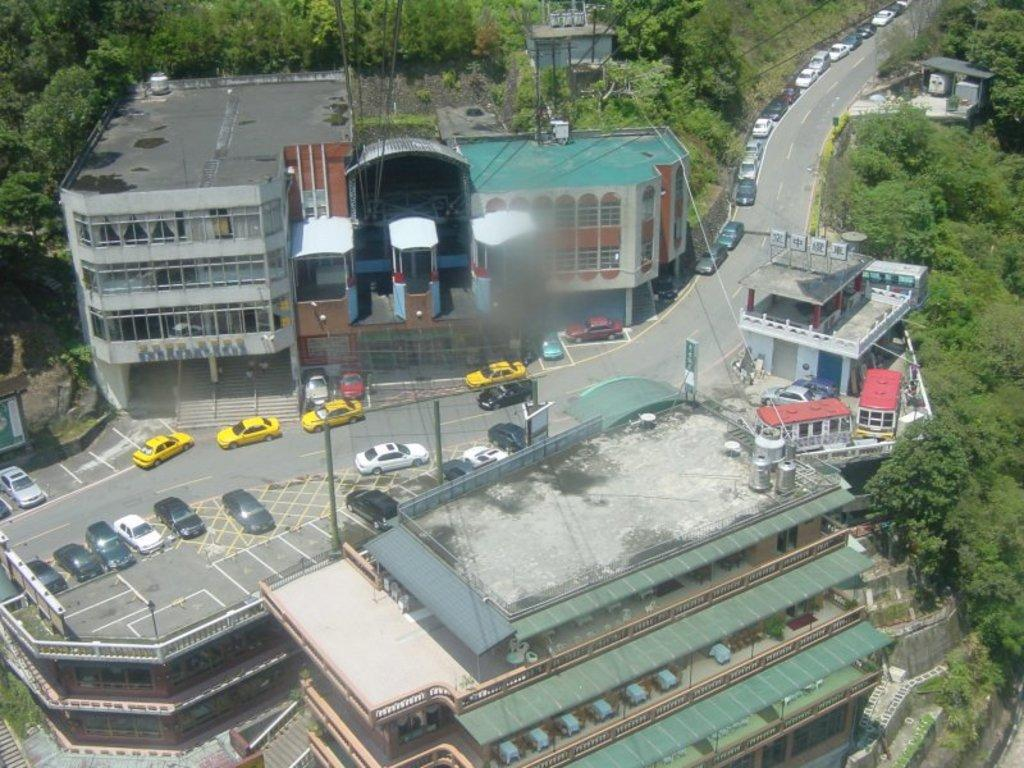What can be seen on the road in the image? There are vehicles on the road in the image. What is visible in the background of the image? There are buildings, poles, and trees in the background of the image. Is there a prison visible in the image? No, there is no prison present in the image. Are there any boots visible in the image? No, there are no boots present in the image. 